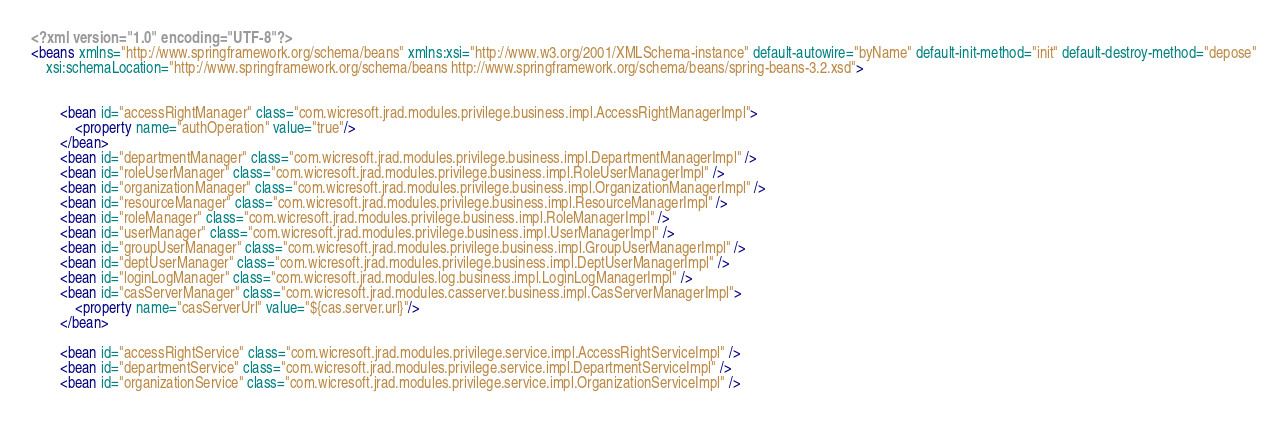<code> <loc_0><loc_0><loc_500><loc_500><_XML_><?xml version="1.0" encoding="UTF-8"?>
<beans xmlns="http://www.springframework.org/schema/beans" xmlns:xsi="http://www.w3.org/2001/XMLSchema-instance" default-autowire="byName" default-init-method="init" default-destroy-method="depose"
	xsi:schemaLocation="http://www.springframework.org/schema/beans http://www.springframework.org/schema/beans/spring-beans-3.2.xsd">


		<bean id="accessRightManager" class="com.wicresoft.jrad.modules.privilege.business.impl.AccessRightManagerImpl">
			<property name="authOperation" value="true"/>
		</bean>
		<bean id="departmentManager" class="com.wicresoft.jrad.modules.privilege.business.impl.DepartmentManagerImpl" />
		<bean id="roleUserManager" class="com.wicresoft.jrad.modules.privilege.business.impl.RoleUserManagerImpl" />
		<bean id="organizationManager" class="com.wicresoft.jrad.modules.privilege.business.impl.OrganizationManagerImpl" />
		<bean id="resourceManager" class="com.wicresoft.jrad.modules.privilege.business.impl.ResourceManagerImpl" />
		<bean id="roleManager" class="com.wicresoft.jrad.modules.privilege.business.impl.RoleManagerImpl" />
		<bean id="userManager" class="com.wicresoft.jrad.modules.privilege.business.impl.UserManagerImpl" />
		<bean id="groupUserManager" class="com.wicresoft.jrad.modules.privilege.business.impl.GroupUserManagerImpl" />
		<bean id="deptUserManager" class="com.wicresoft.jrad.modules.privilege.business.impl.DeptUserManagerImpl" />
		<bean id="loginLogManager" class="com.wicresoft.jrad.modules.log.business.impl.LoginLogManagerImpl" />
		<bean id="casServerManager" class="com.wicresoft.jrad.modules.casserver.business.impl.CasServerManagerImpl">
			<property name="casServerUrl" value="${cas.server.url}"/>
		</bean>
		
		<bean id="accessRightService" class="com.wicresoft.jrad.modules.privilege.service.impl.AccessRightServiceImpl" />
		<bean id="departmentService" class="com.wicresoft.jrad.modules.privilege.service.impl.DepartmentServiceImpl" />
		<bean id="organizationService" class="com.wicresoft.jrad.modules.privilege.service.impl.OrganizationServiceImpl" /></code> 